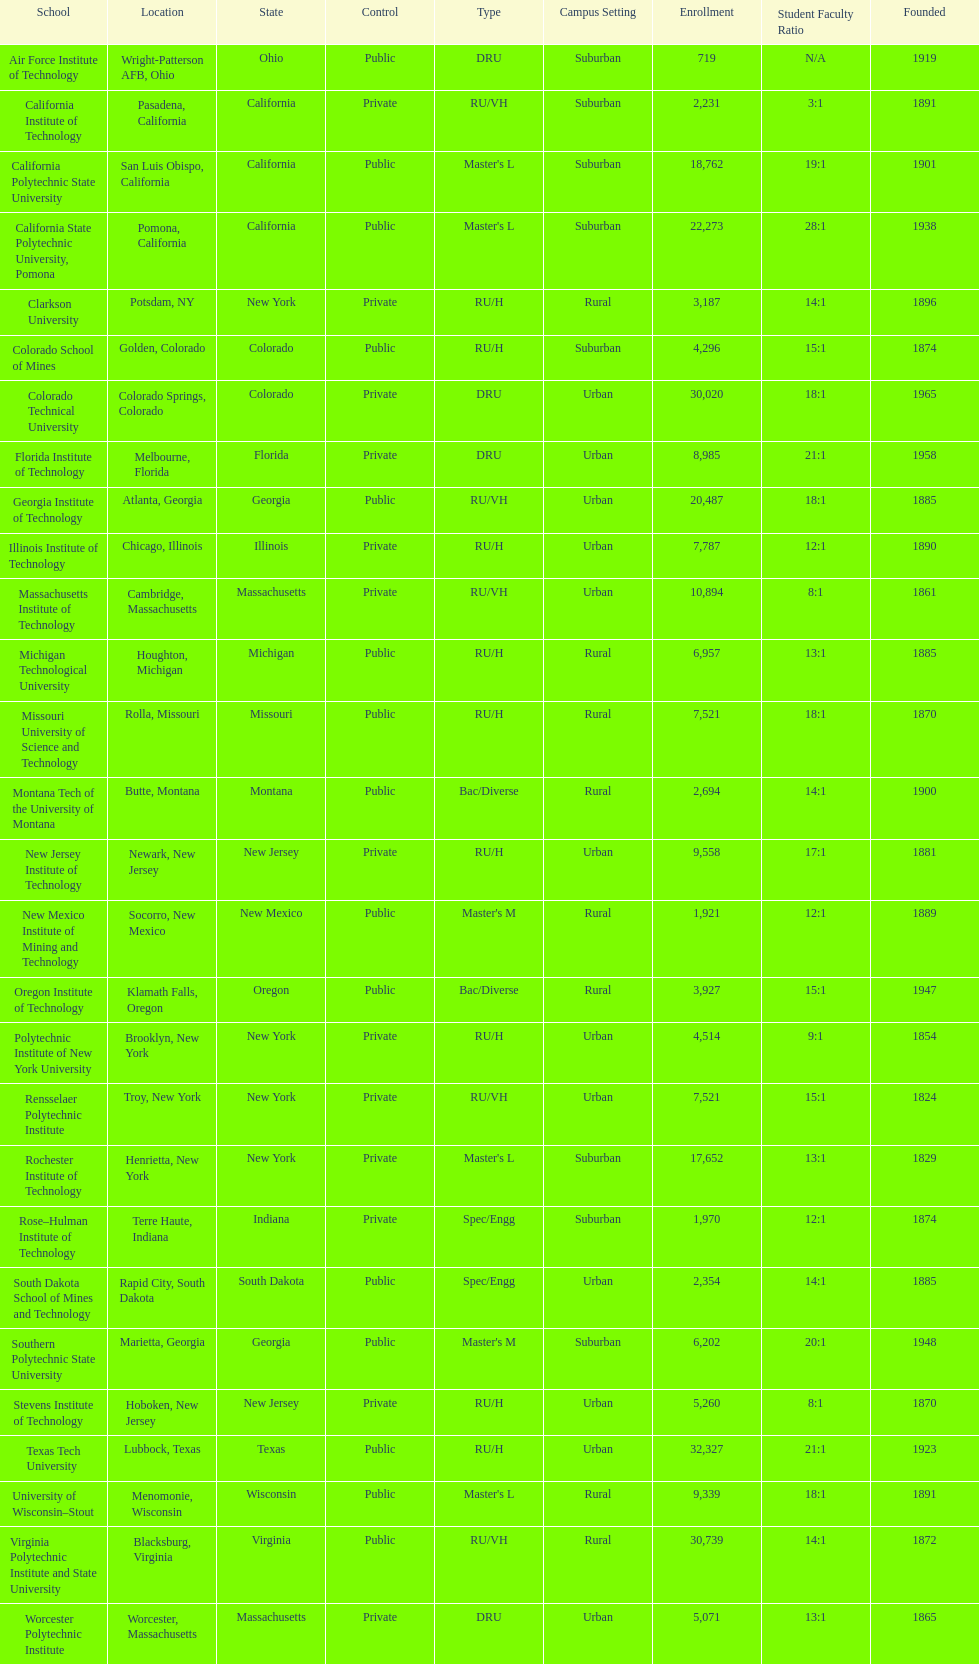Which us technological university has the top enrollment numbers? Texas Tech University. 